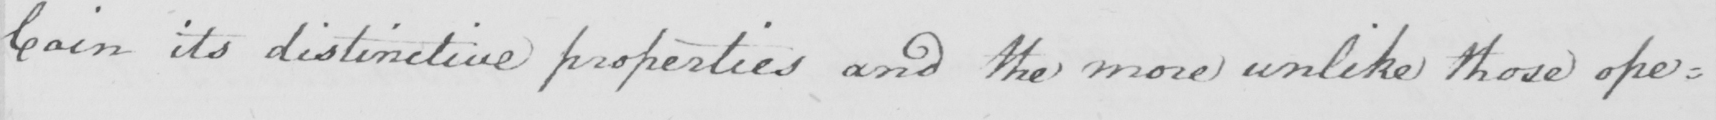Transcribe the text shown in this historical manuscript line. Coin its distinctive properties and the more unlike those ope= 